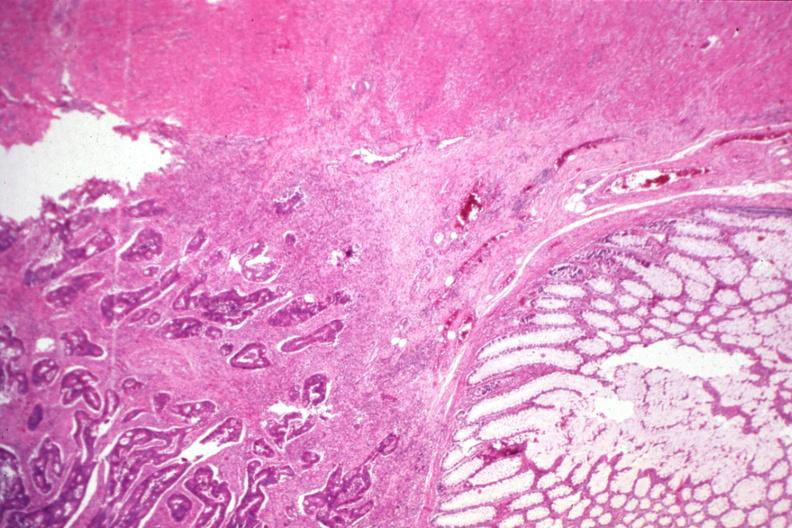s gastrointestinal present?
Answer the question using a single word or phrase. No 